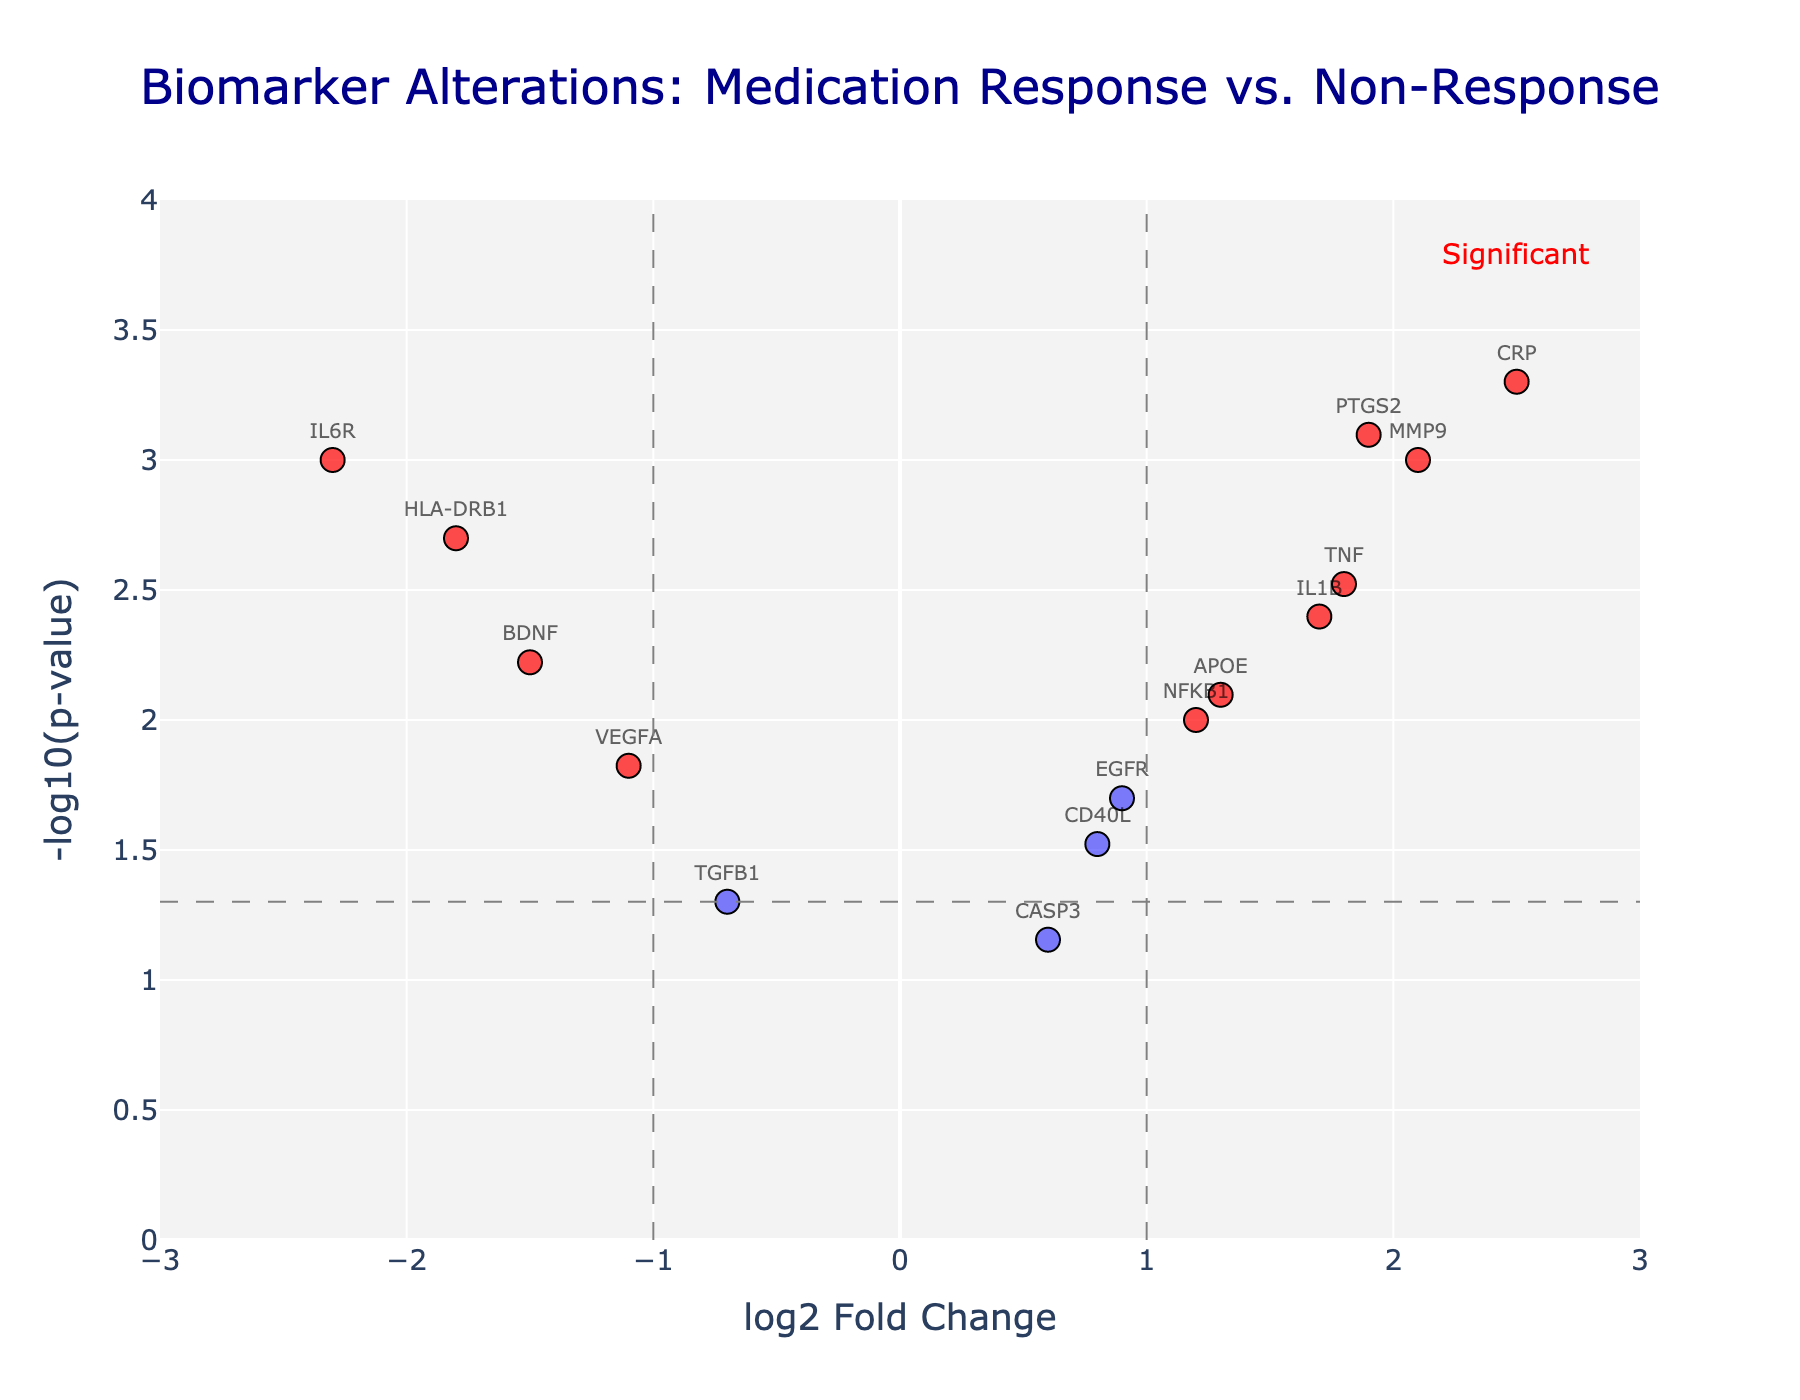what is the title of the plot? The title is located at the top center of the plot, and it provides a summary of what the graph is about.
Answer: Biomarker Alterations: Medication Response vs. Non-Response How many data points have a log2 Fold Change greater than 1 and are significant (p-value < 0.05)? Check the points on the plot with x values greater than 1 and y values above the horizontal threshold line (p-value < 0.05). Count these points.
Answer: 6 Which biomarker has the highest -log10(p-value)? The highest -log10(p-value) corresponds to the highest point on the y-axis. Identify the gene associated with this point.
Answer: CRP What is the log2 Fold Change and p-value for IL6R? Find the label IL6R on the plot and refer to its horizontal (log2 Fold Change) and vertical (-log10(p-value)) coordinates. Convert the -log10(p-value) back to the p-value.
Answer: log2 Fold Change: -2.3, p-value: 0.001 Which anti-inflammatory gene has a significant negative log2 Fold Change (less than -1)? Locate data points with log2 Fold Change less than -1 and significant (above the horizontal threshold line). Identify the genes related to inflammation.
Answer: IL6R and HLA-DRB1 Which of the biomarkers have both a log2 Fold Change close to zero (between -0.7 and 0.7) and are not significant? Look for points with x values between -0.7 and 0.7 and y values below the significance threshold line.
Answer: CASP3, CD40L, TGFB1 